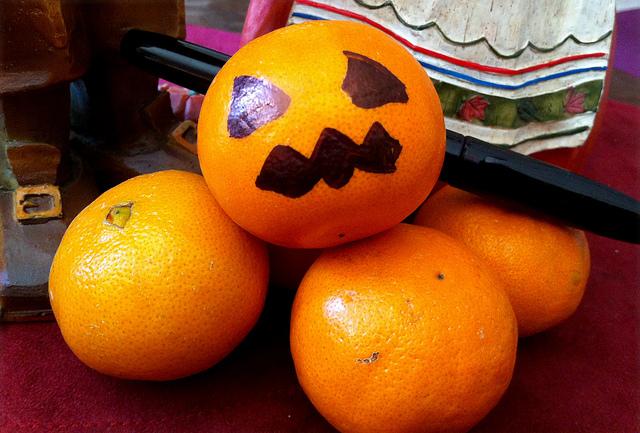How many oranges can you see?
Short answer required. 4. Are these the same kind of fruit?
Answer briefly. Yes. What produce of the same color is usually carved with this design?
Write a very short answer. Pumpkin. What type of fruit has a face marked on it?
Short answer required. Orange. 